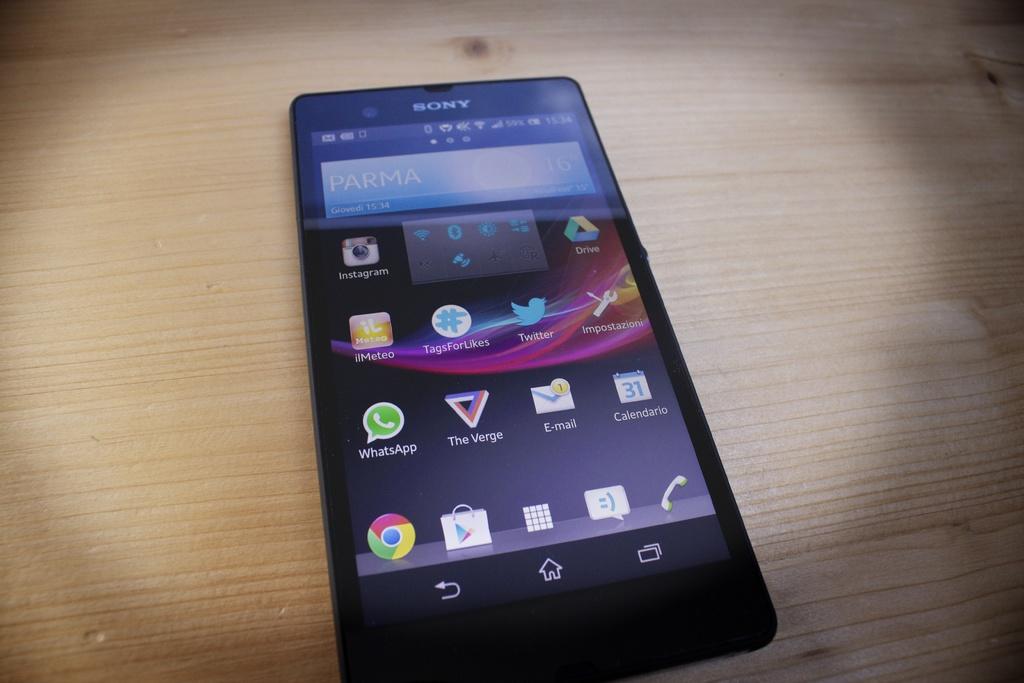Who is the manufacturer of the phone?
Make the answer very short. Sony. What brand is the phone?
Offer a very short reply. Sony. 